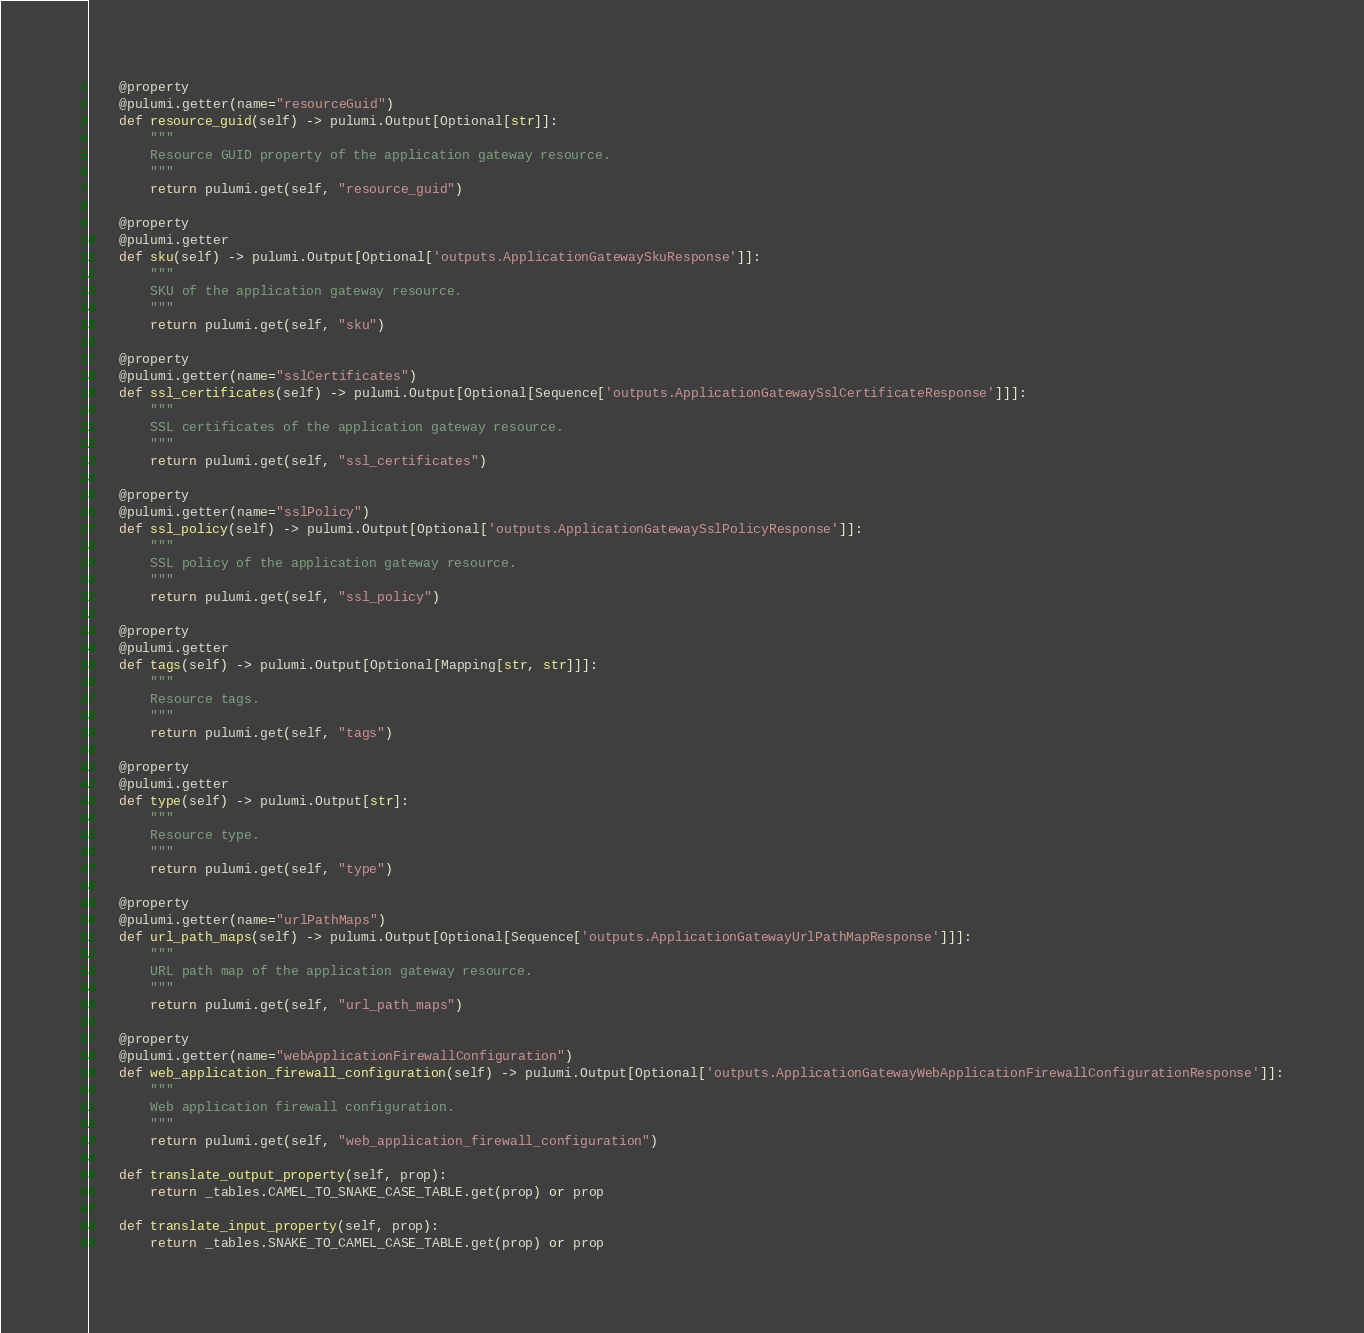<code> <loc_0><loc_0><loc_500><loc_500><_Python_>
    @property
    @pulumi.getter(name="resourceGuid")
    def resource_guid(self) -> pulumi.Output[Optional[str]]:
        """
        Resource GUID property of the application gateway resource.
        """
        return pulumi.get(self, "resource_guid")

    @property
    @pulumi.getter
    def sku(self) -> pulumi.Output[Optional['outputs.ApplicationGatewaySkuResponse']]:
        """
        SKU of the application gateway resource.
        """
        return pulumi.get(self, "sku")

    @property
    @pulumi.getter(name="sslCertificates")
    def ssl_certificates(self) -> pulumi.Output[Optional[Sequence['outputs.ApplicationGatewaySslCertificateResponse']]]:
        """
        SSL certificates of the application gateway resource.
        """
        return pulumi.get(self, "ssl_certificates")

    @property
    @pulumi.getter(name="sslPolicy")
    def ssl_policy(self) -> pulumi.Output[Optional['outputs.ApplicationGatewaySslPolicyResponse']]:
        """
        SSL policy of the application gateway resource.
        """
        return pulumi.get(self, "ssl_policy")

    @property
    @pulumi.getter
    def tags(self) -> pulumi.Output[Optional[Mapping[str, str]]]:
        """
        Resource tags.
        """
        return pulumi.get(self, "tags")

    @property
    @pulumi.getter
    def type(self) -> pulumi.Output[str]:
        """
        Resource type.
        """
        return pulumi.get(self, "type")

    @property
    @pulumi.getter(name="urlPathMaps")
    def url_path_maps(self) -> pulumi.Output[Optional[Sequence['outputs.ApplicationGatewayUrlPathMapResponse']]]:
        """
        URL path map of the application gateway resource.
        """
        return pulumi.get(self, "url_path_maps")

    @property
    @pulumi.getter(name="webApplicationFirewallConfiguration")
    def web_application_firewall_configuration(self) -> pulumi.Output[Optional['outputs.ApplicationGatewayWebApplicationFirewallConfigurationResponse']]:
        """
        Web application firewall configuration.
        """
        return pulumi.get(self, "web_application_firewall_configuration")

    def translate_output_property(self, prop):
        return _tables.CAMEL_TO_SNAKE_CASE_TABLE.get(prop) or prop

    def translate_input_property(self, prop):
        return _tables.SNAKE_TO_CAMEL_CASE_TABLE.get(prop) or prop

</code> 